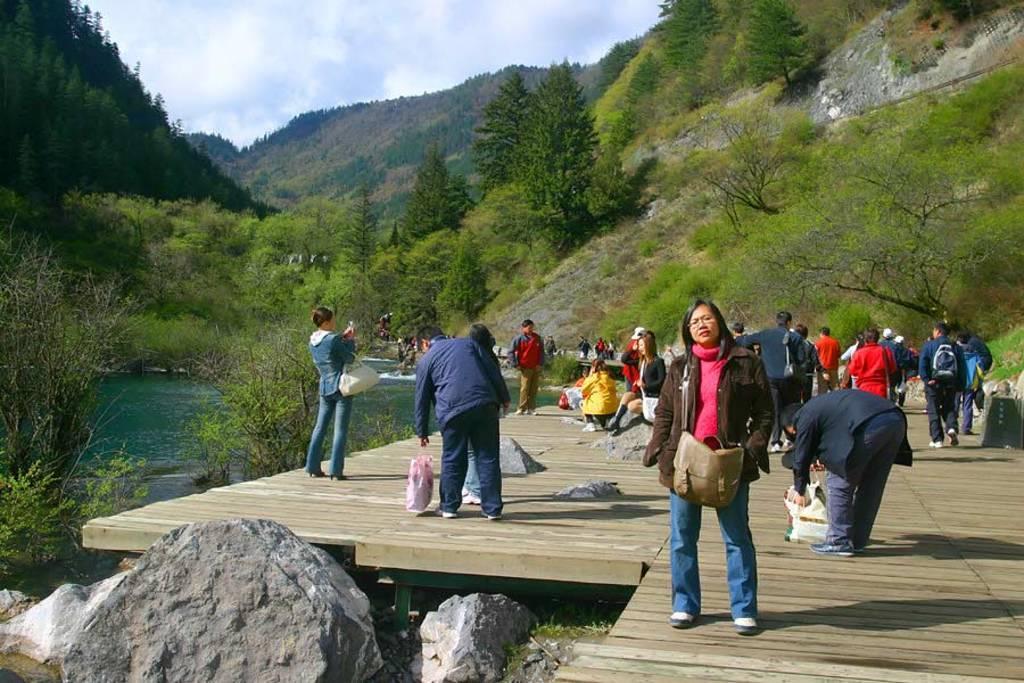Can you describe this image briefly? In this picture I can see a group of people in the middle. At the bottom there are stones, on the left side there is water, in the background there are trees. At the top there is the sky. 